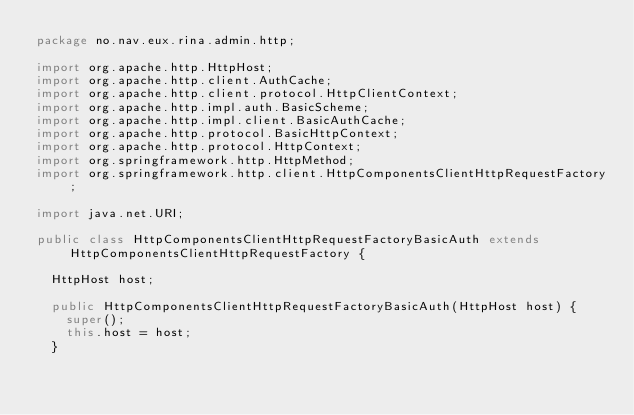Convert code to text. <code><loc_0><loc_0><loc_500><loc_500><_Java_>package no.nav.eux.rina.admin.http;

import org.apache.http.HttpHost;
import org.apache.http.client.AuthCache;
import org.apache.http.client.protocol.HttpClientContext;
import org.apache.http.impl.auth.BasicScheme;
import org.apache.http.impl.client.BasicAuthCache;
import org.apache.http.protocol.BasicHttpContext;
import org.apache.http.protocol.HttpContext;
import org.springframework.http.HttpMethod;
import org.springframework.http.client.HttpComponentsClientHttpRequestFactory;

import java.net.URI;

public class HttpComponentsClientHttpRequestFactoryBasicAuth extends HttpComponentsClientHttpRequestFactory {
  
  HttpHost host;
  
  public HttpComponentsClientHttpRequestFactoryBasicAuth(HttpHost host) {
    super();
    this.host = host;
  }
  </code> 